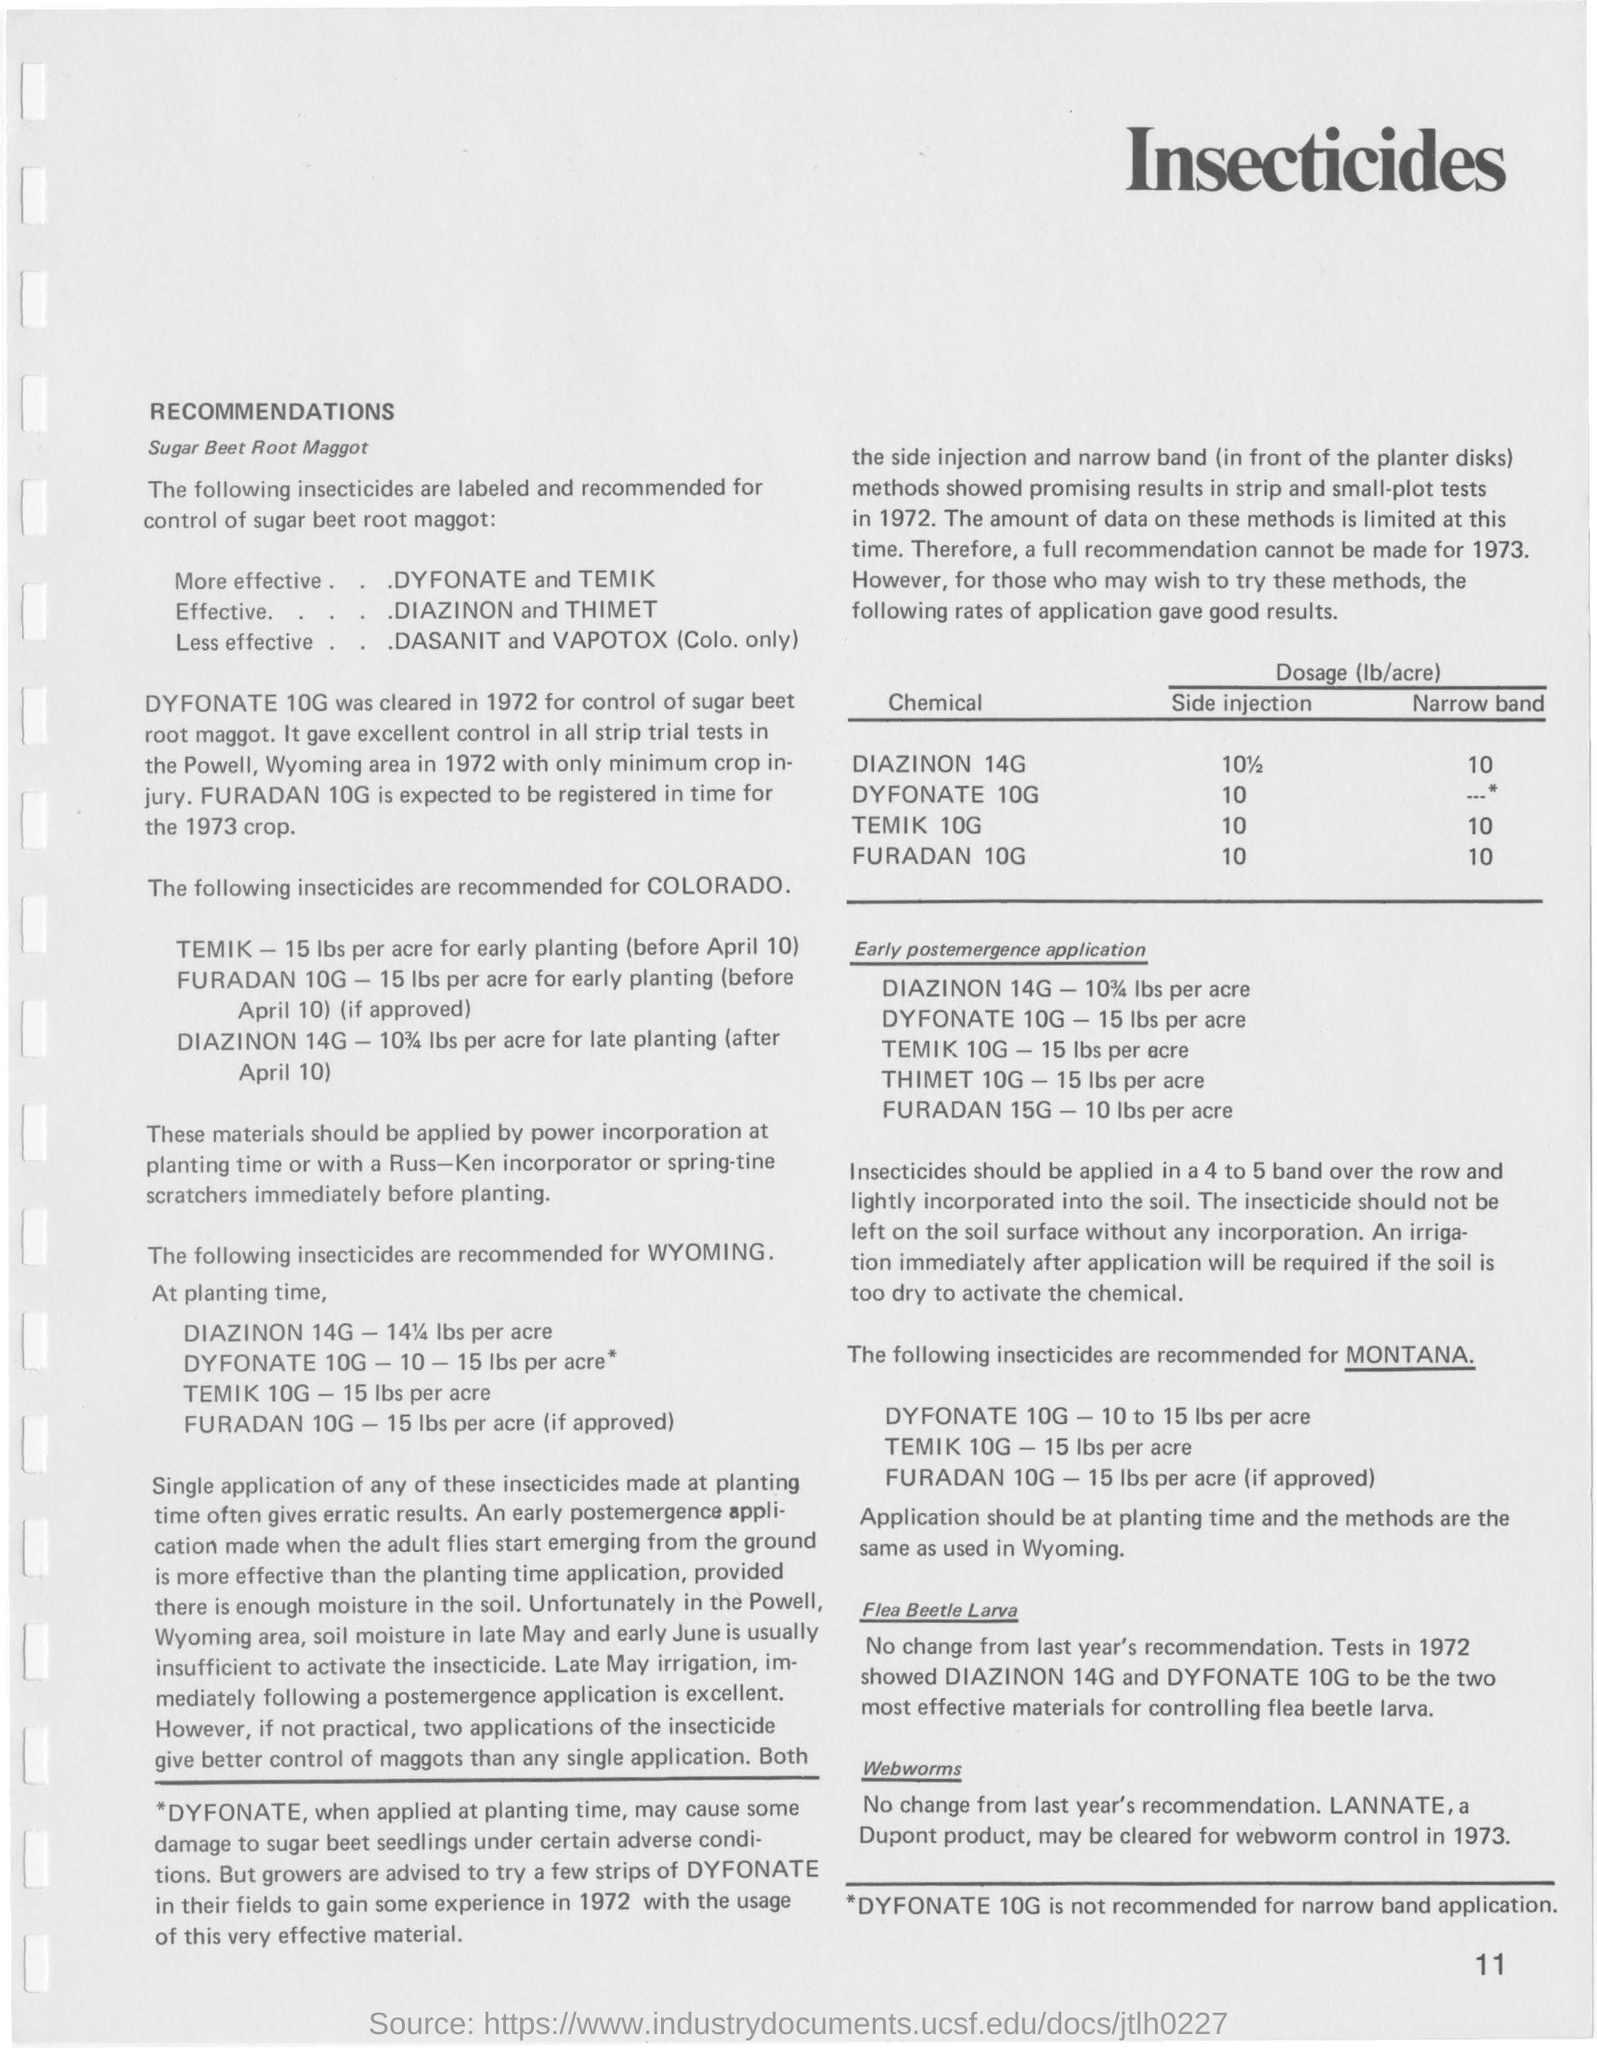Which insecticides are more effective for the control of sugar beet root maggot?
Your answer should be very brief. DYFONATE and TEMIK. Which insecticides are less effective for the control of sugar beet root maggot?
Offer a very short reply. Dasanit and Vapotox (Colo. only). What is the dosage(lb/acre) for Dyfonate 10G by side injection method?
Give a very brief answer. 10. What is the dosage of Temik 10G at early post emergence application?
Offer a terse response. 15 lbs per acre. What is the dosage of FURADAN 15G at early post emergence application?
Offer a very short reply. 10 lbs per  acre. 